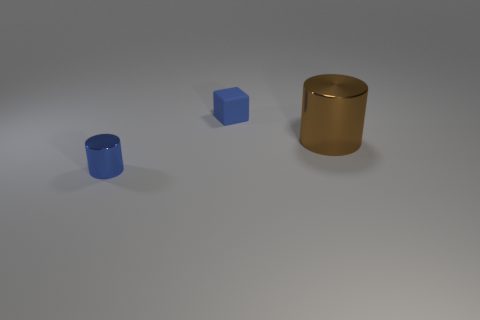Is there any other thing that is the same size as the brown metallic cylinder?
Offer a very short reply. No. Is there any other thing that has the same shape as the rubber thing?
Keep it short and to the point. No. Does the blue block have the same size as the brown shiny object?
Make the answer very short. No. What number of other objects are the same size as the brown thing?
Your answer should be very brief. 0. What is the color of the small cylinder that is made of the same material as the big cylinder?
Keep it short and to the point. Blue. Are there fewer tiny blue rubber cubes than tiny blue things?
Provide a short and direct response. Yes. How many yellow objects are either large shiny objects or small things?
Your response must be concise. 0. What number of things are both behind the blue metal thing and to the left of the big brown cylinder?
Your answer should be very brief. 1. Do the small cylinder and the big brown object have the same material?
Make the answer very short. Yes. There is a blue object that is the same size as the rubber cube; what shape is it?
Your answer should be very brief. Cylinder. 